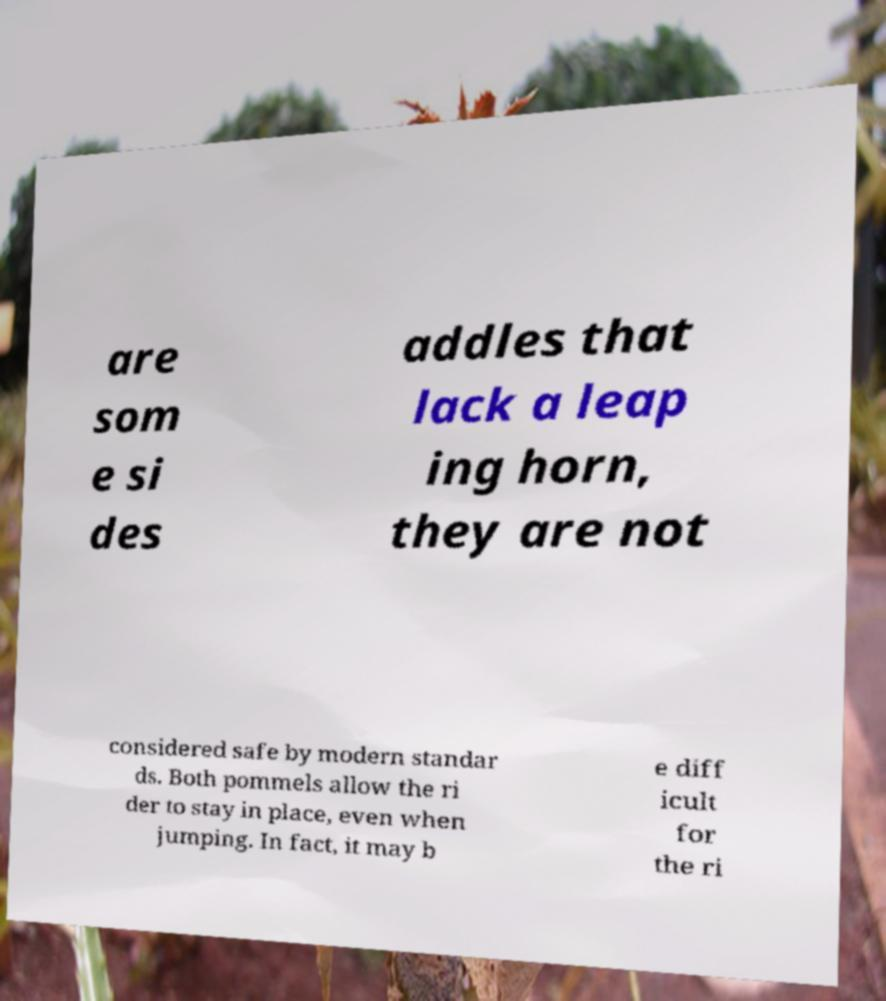There's text embedded in this image that I need extracted. Can you transcribe it verbatim? are som e si des addles that lack a leap ing horn, they are not considered safe by modern standar ds. Both pommels allow the ri der to stay in place, even when jumping. In fact, it may b e diff icult for the ri 